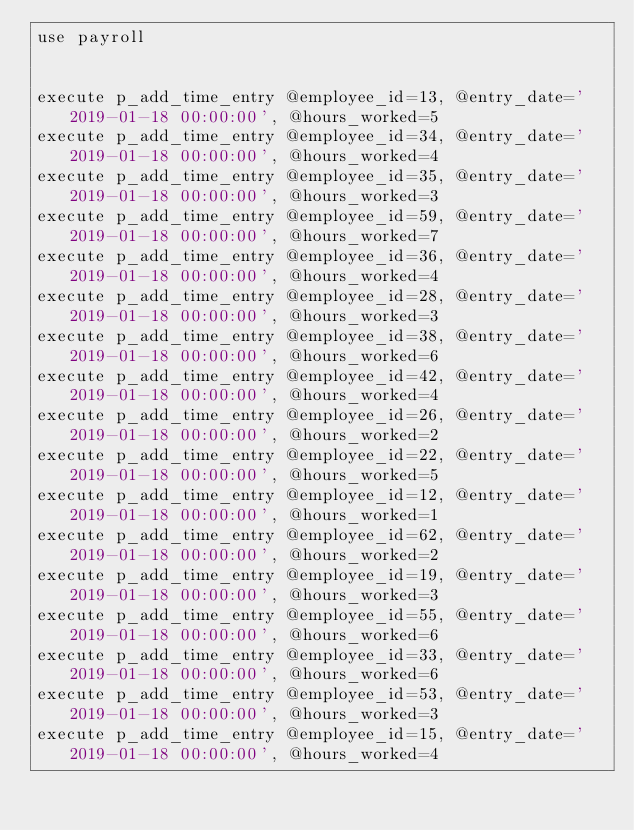<code> <loc_0><loc_0><loc_500><loc_500><_SQL_>use payroll


execute p_add_time_entry @employee_id=13, @entry_date='2019-01-18 00:00:00', @hours_worked=5
execute p_add_time_entry @employee_id=34, @entry_date='2019-01-18 00:00:00', @hours_worked=4
execute p_add_time_entry @employee_id=35, @entry_date='2019-01-18 00:00:00', @hours_worked=3
execute p_add_time_entry @employee_id=59, @entry_date='2019-01-18 00:00:00', @hours_worked=7
execute p_add_time_entry @employee_id=36, @entry_date='2019-01-18 00:00:00', @hours_worked=4
execute p_add_time_entry @employee_id=28, @entry_date='2019-01-18 00:00:00', @hours_worked=3
execute p_add_time_entry @employee_id=38, @entry_date='2019-01-18 00:00:00', @hours_worked=6
execute p_add_time_entry @employee_id=42, @entry_date='2019-01-18 00:00:00', @hours_worked=4
execute p_add_time_entry @employee_id=26, @entry_date='2019-01-18 00:00:00', @hours_worked=2
execute p_add_time_entry @employee_id=22, @entry_date='2019-01-18 00:00:00', @hours_worked=5
execute p_add_time_entry @employee_id=12, @entry_date='2019-01-18 00:00:00', @hours_worked=1
execute p_add_time_entry @employee_id=62, @entry_date='2019-01-18 00:00:00', @hours_worked=2
execute p_add_time_entry @employee_id=19, @entry_date='2019-01-18 00:00:00', @hours_worked=3
execute p_add_time_entry @employee_id=55, @entry_date='2019-01-18 00:00:00', @hours_worked=6
execute p_add_time_entry @employee_id=33, @entry_date='2019-01-18 00:00:00', @hours_worked=6
execute p_add_time_entry @employee_id=53, @entry_date='2019-01-18 00:00:00', @hours_worked=3
execute p_add_time_entry @employee_id=15, @entry_date='2019-01-18 00:00:00', @hours_worked=4</code> 